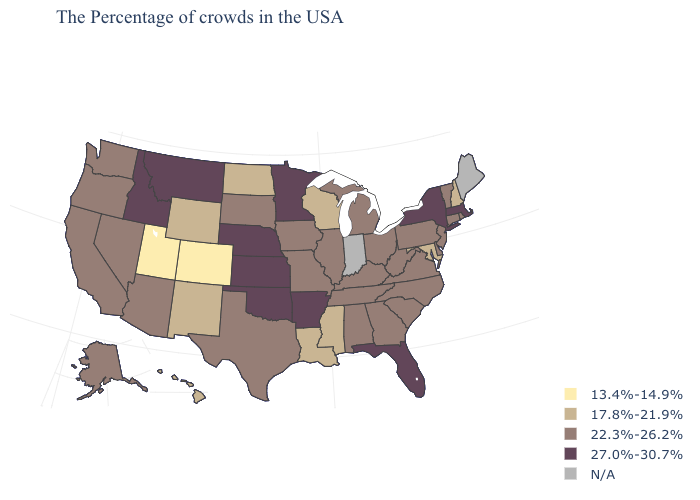Which states have the lowest value in the West?
Write a very short answer. Colorado, Utah. Does the map have missing data?
Write a very short answer. Yes. Among the states that border North Dakota , which have the highest value?
Give a very brief answer. Minnesota, Montana. What is the highest value in the MidWest ?
Short answer required. 27.0%-30.7%. Name the states that have a value in the range 22.3%-26.2%?
Answer briefly. Rhode Island, Vermont, Connecticut, New Jersey, Delaware, Pennsylvania, Virginia, North Carolina, South Carolina, West Virginia, Ohio, Georgia, Michigan, Kentucky, Alabama, Tennessee, Illinois, Missouri, Iowa, Texas, South Dakota, Arizona, Nevada, California, Washington, Oregon, Alaska. What is the lowest value in the USA?
Write a very short answer. 13.4%-14.9%. What is the value of New Hampshire?
Be succinct. 17.8%-21.9%. Is the legend a continuous bar?
Write a very short answer. No. Among the states that border Minnesota , does Iowa have the lowest value?
Be succinct. No. Among the states that border Michigan , which have the lowest value?
Short answer required. Wisconsin. Name the states that have a value in the range 13.4%-14.9%?
Be succinct. Colorado, Utah. Name the states that have a value in the range 13.4%-14.9%?
Answer briefly. Colorado, Utah. Name the states that have a value in the range 22.3%-26.2%?
Be succinct. Rhode Island, Vermont, Connecticut, New Jersey, Delaware, Pennsylvania, Virginia, North Carolina, South Carolina, West Virginia, Ohio, Georgia, Michigan, Kentucky, Alabama, Tennessee, Illinois, Missouri, Iowa, Texas, South Dakota, Arizona, Nevada, California, Washington, Oregon, Alaska. 